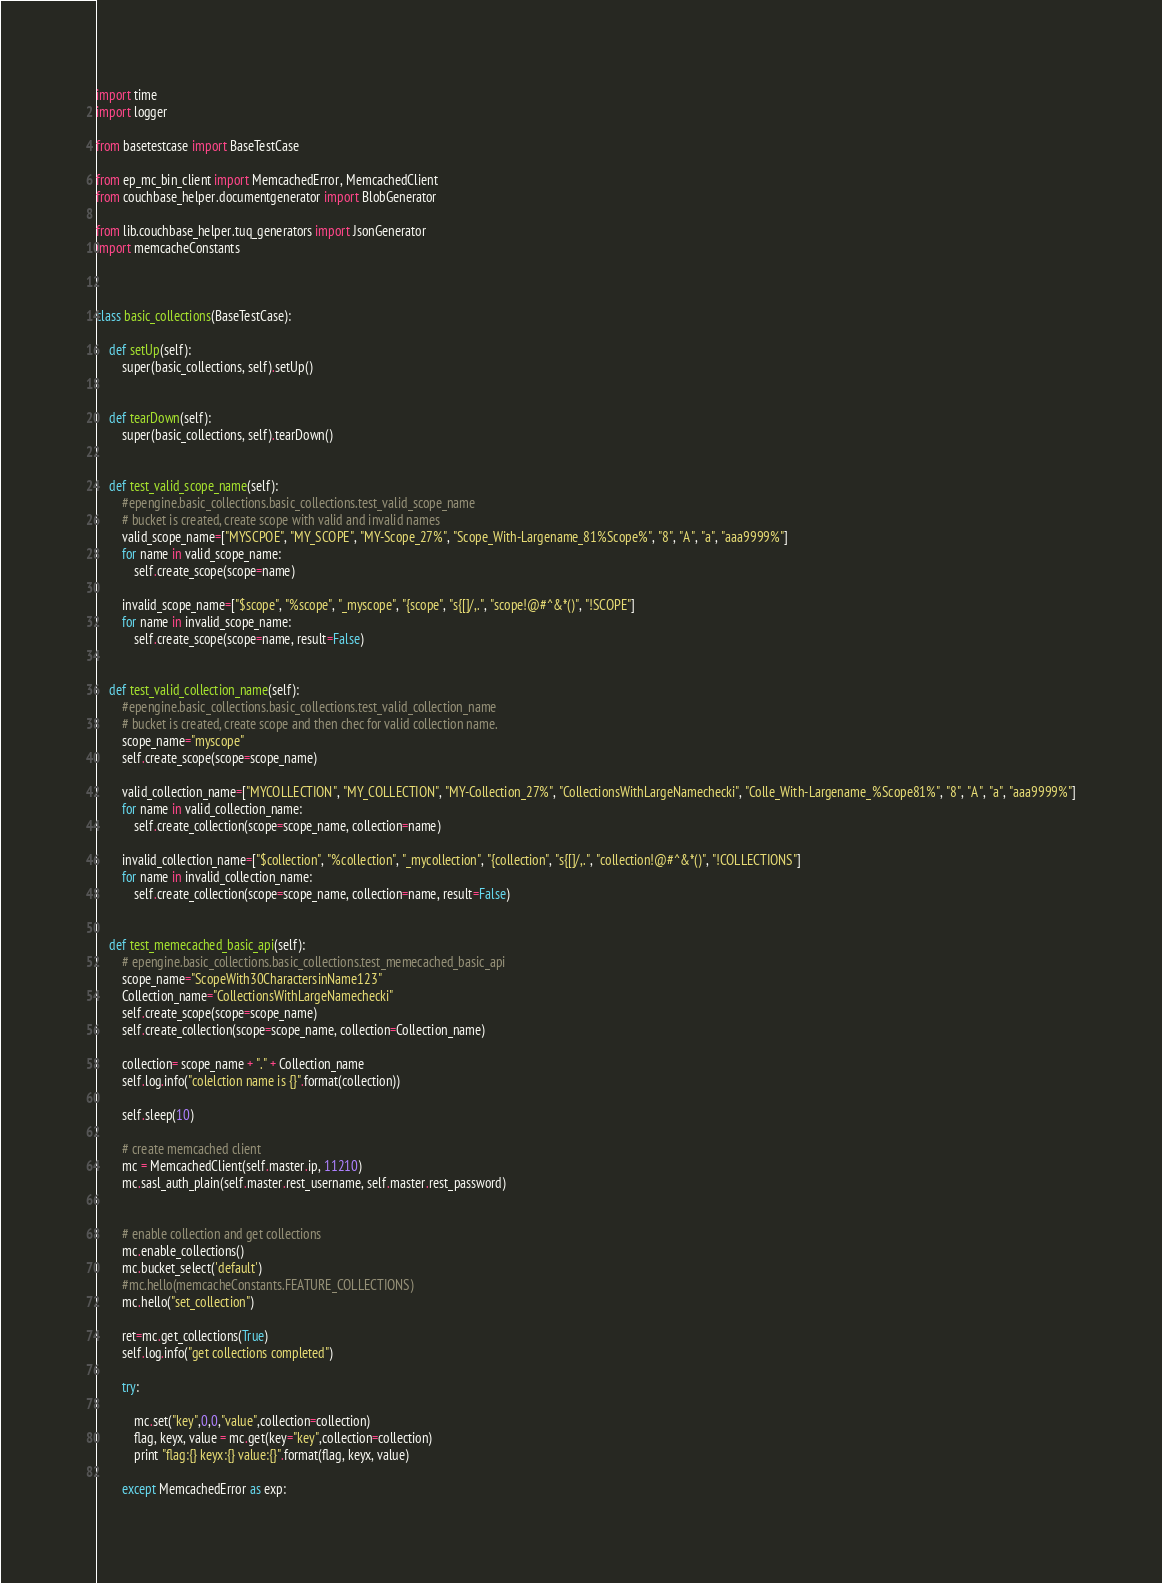<code> <loc_0><loc_0><loc_500><loc_500><_Python_>import time
import logger

from basetestcase import BaseTestCase

from ep_mc_bin_client import MemcachedError, MemcachedClient
from couchbase_helper.documentgenerator import BlobGenerator

from lib.couchbase_helper.tuq_generators import JsonGenerator
import memcacheConstants



class basic_collections(BaseTestCase):

    def setUp(self):
        super(basic_collections, self).setUp()


    def tearDown(self):
        super(basic_collections, self).tearDown()


    def test_valid_scope_name(self):
        #epengine.basic_collections.basic_collections.test_valid_scope_name
        # bucket is created, create scope with valid and invalid names
        valid_scope_name=["MYSCPOE", "MY_SCOPE", "MY-Scope_27%", "Scope_With-Largename_81%Scope%", "8", "A", "a", "aaa9999%"]
        for name in valid_scope_name:
            self.create_scope(scope=name)

        invalid_scope_name=["$scope", "%scope", "_myscope", "{scope", "s{[]/,.", "scope!@#^&*()", "!SCOPE"]
        for name in invalid_scope_name:
            self.create_scope(scope=name, result=False)


    def test_valid_collection_name(self):
        #epengine.basic_collections.basic_collections.test_valid_collection_name
        # bucket is created, create scope and then chec for valid collection name.
        scope_name="myscope"
        self.create_scope(scope=scope_name)

        valid_collection_name=["MYCOLLECTION", "MY_COLLECTION", "MY-Collection_27%", "CollectionsWithLargeNamechecki", "Colle_With-Largename_%Scope81%", "8", "A", "a", "aaa9999%"]
        for name in valid_collection_name:
            self.create_collection(scope=scope_name, collection=name)

        invalid_collection_name=["$collection", "%collection", "_mycollection", "{collection", "s{[]/,.", "collection!@#^&*()", "!COLLECTIONS"]
        for name in invalid_collection_name:
            self.create_collection(scope=scope_name, collection=name, result=False)


    def test_memecached_basic_api(self):
        # epengine.basic_collections.basic_collections.test_memecached_basic_api
        scope_name="ScopeWith30CharactersinName123"
        Collection_name="CollectionsWithLargeNamechecki"
        self.create_scope(scope=scope_name)
        self.create_collection(scope=scope_name, collection=Collection_name)

        collection= scope_name + "." + Collection_name
        self.log.info("colelction name is {}".format(collection))

        self.sleep(10)

        # create memcached client
        mc = MemcachedClient(self.master.ip, 11210)
        mc.sasl_auth_plain(self.master.rest_username, self.master.rest_password)


        # enable collection and get collections
        mc.enable_collections()
        mc.bucket_select('default')
        #mc.hello(memcacheConstants.FEATURE_COLLECTIONS)
        mc.hello("set_collection")

        ret=mc.get_collections(True)
        self.log.info("get collections completed")

        try:

            mc.set("key",0,0,"value",collection=collection)
            flag, keyx, value = mc.get(key="key",collection=collection)
            print "flag:{} keyx:{} value:{}".format(flag, keyx, value)

        except MemcachedError as exp:</code> 